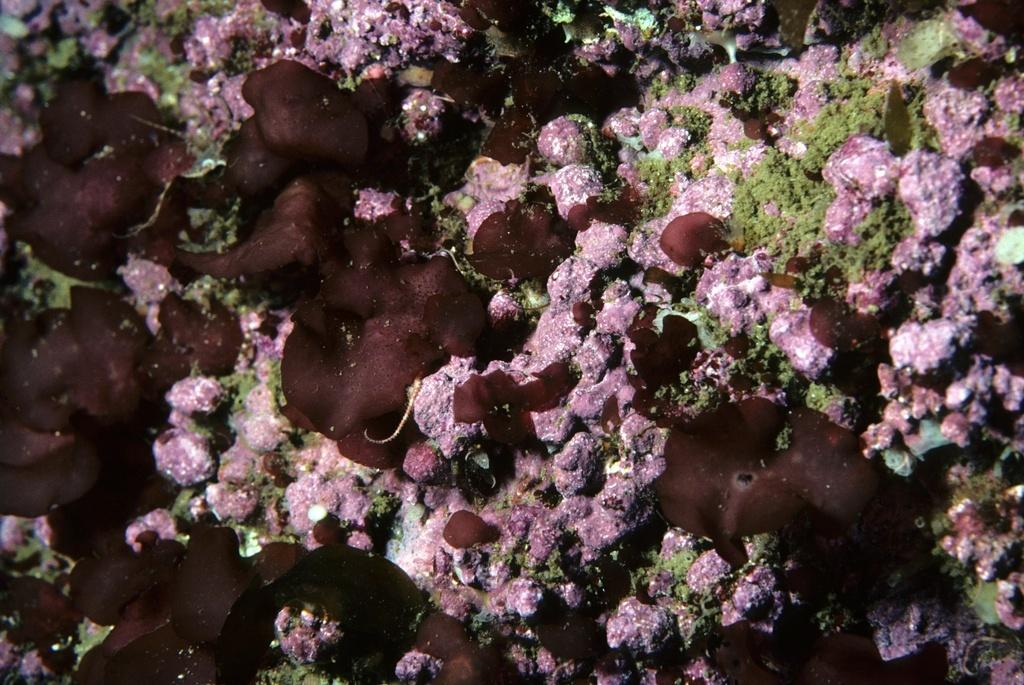What type of objects resemble coral leaves in the image? There are objects that resemble coral leaves in the image. What kind of objects are present in the image? There are marine objects in the image. What is the purpose of the grandmother in the image? There is no grandmother present in the image. 